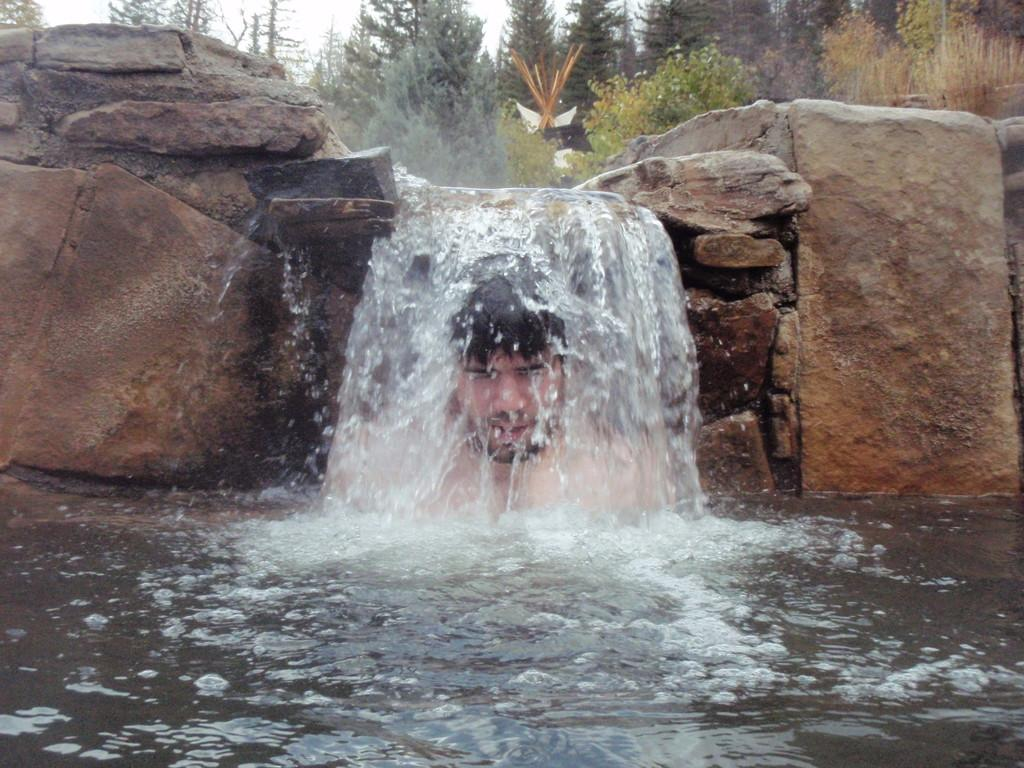What is happening in the center of the image? Water is falling from rocks in the center of the image. Can you describe the person in the image? There is a person in the water. What can be seen in the background of the image? The sky and trees are visible in the background of the image. What type of impulse can be seen affecting the water in the image? There is no mention of an impulse affecting the water in the image. The water is simply falling from the rocks. How many waves can be seen in the image? There are no waves present in the image; it features water falling from rocks. 